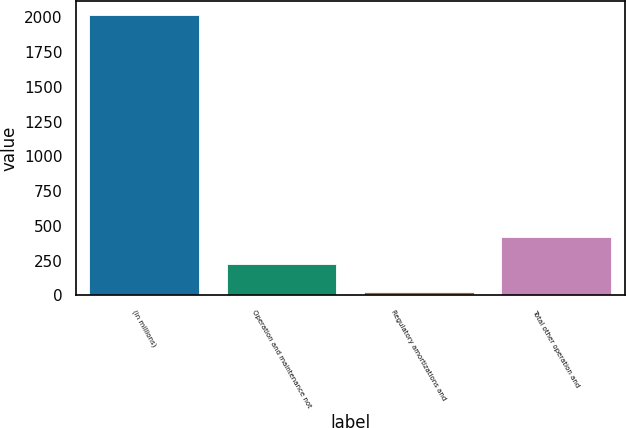Convert chart. <chart><loc_0><loc_0><loc_500><loc_500><bar_chart><fcel>(in millions)<fcel>Operation and maintenance not<fcel>Regulatory amortizations and<fcel>Total other operation and<nl><fcel>2016<fcel>222.84<fcel>23.6<fcel>422.08<nl></chart> 